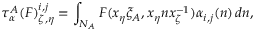Convert formula to latex. <formula><loc_0><loc_0><loc_500><loc_500>\tau _ { \alpha } ^ { A } ( F ) _ { \zeta , \eta } ^ { i , j } = \int _ { N _ { A } } F ( x _ { \eta } \xi _ { A } , x _ { \eta } n x _ { \zeta } ^ { - 1 } ) \alpha _ { i , j } ( n ) \, d n ,</formula> 